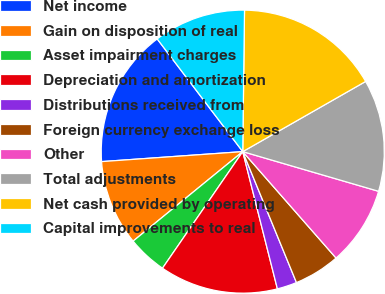<chart> <loc_0><loc_0><loc_500><loc_500><pie_chart><fcel>Net income<fcel>Gain on disposition of real<fcel>Asset impairment charges<fcel>Depreciation and amortization<fcel>Distributions received from<fcel>Foreign currency exchange loss<fcel>Other<fcel>Total adjustments<fcel>Net cash provided by operating<fcel>Capital improvements to real<nl><fcel>15.79%<fcel>9.77%<fcel>4.51%<fcel>13.53%<fcel>2.26%<fcel>5.26%<fcel>9.02%<fcel>12.78%<fcel>16.54%<fcel>10.53%<nl></chart> 